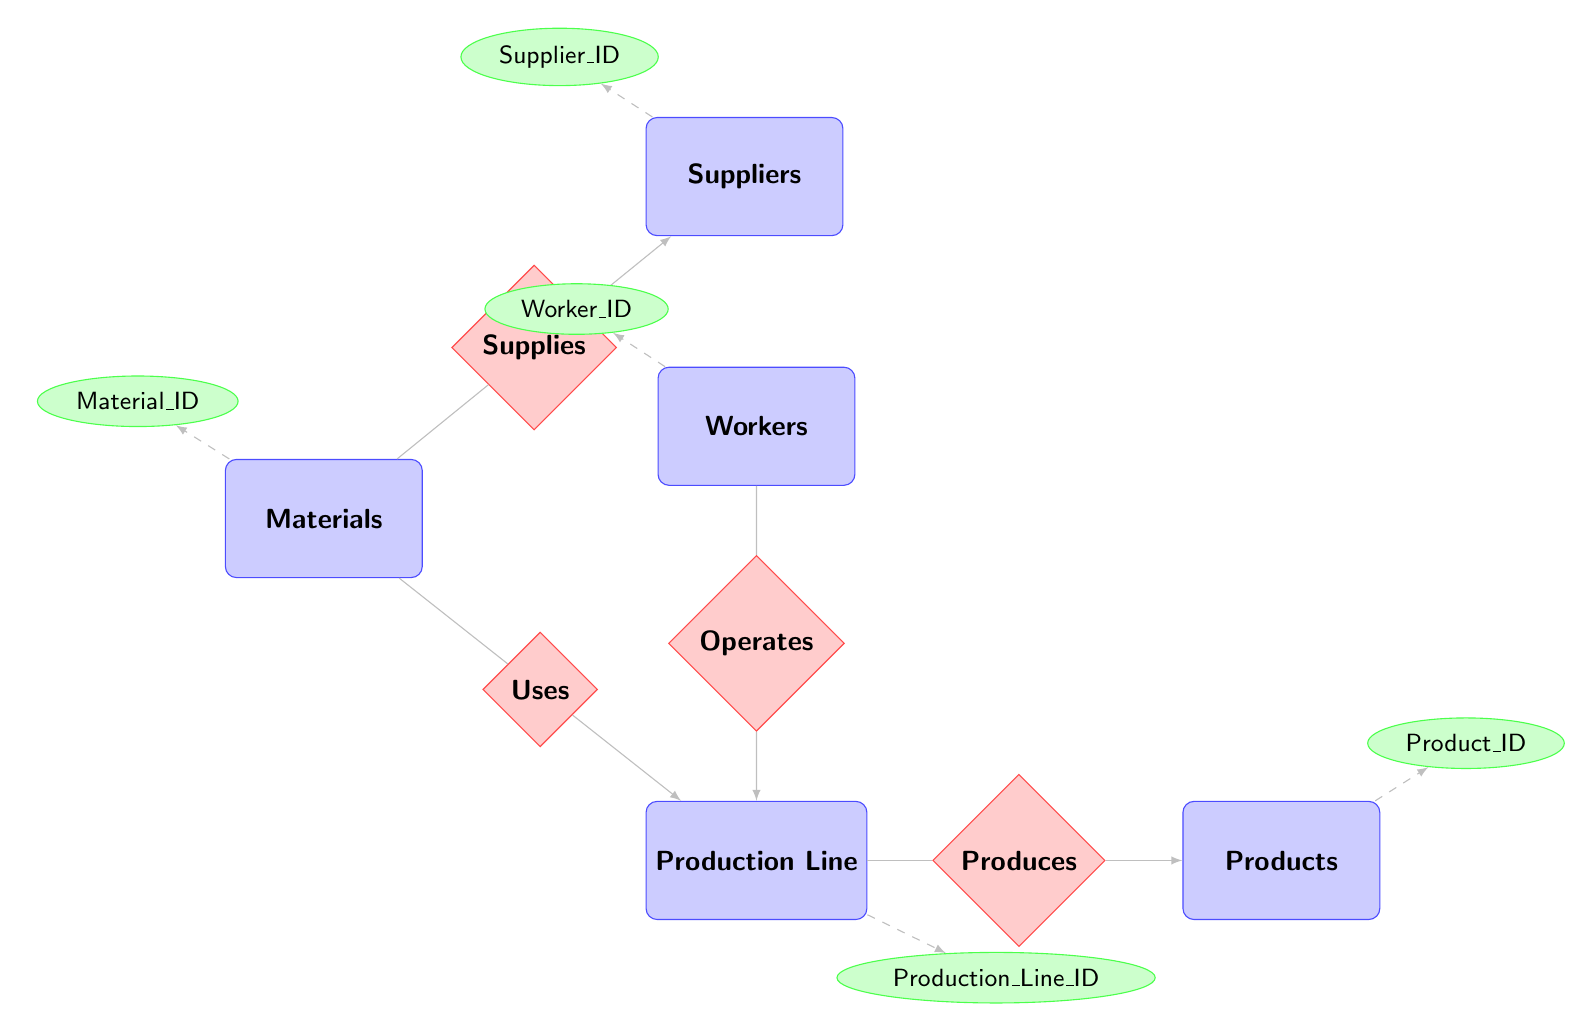What entities are present in the diagram? The diagram includes five entities: Materials, Suppliers, Production Line, Products, and Workers.
Answer: Materials, Suppliers, Production Line, Products, Workers How many relationships are there in total? The diagram contains four relationships: Supplies, Uses, Produces, and Operates, making a total of four relationships.
Answer: 4 What is the Efficiency Rating of the Production Line entity? The Production Line entity has an attribute called Efficiency_Rating, but its specific value is not indicated in the diagram. Thus, we cannot provide a numeric or descriptive answer based strictly on the diagram contents.
Answer: Not specified Who supplies the materials? The Suppliers entity is related to the Materials entity through the Supplies relationship, indicating that suppliers are responsible for providing materials.
Answer: Suppliers How many attributes does the Workers entity have? The Workers entity has four attributes: Worker_ID, Name, Role, and Training_Status. Therefore, the count of attributes is four.
Answer: 4 What is the primary function of the Produces relationship? The Produces relationship connects the Production Line to the Products entity, indicating that the primary function is to denote which products are produced by which production lines.
Answer: To denote production Which entities are associated with the Uses relationship? The Uses relationship connects the Materials entity with the Production Line entity, indicating that materials are utilized in the production process.
Answer: Materials, Production Line In the context of operations, what role do workers have? Workers operate the Production Line as indicated by the Operates relationship, which shows their involvement in production activities through shifts and daily hours.
Answer: Operate 